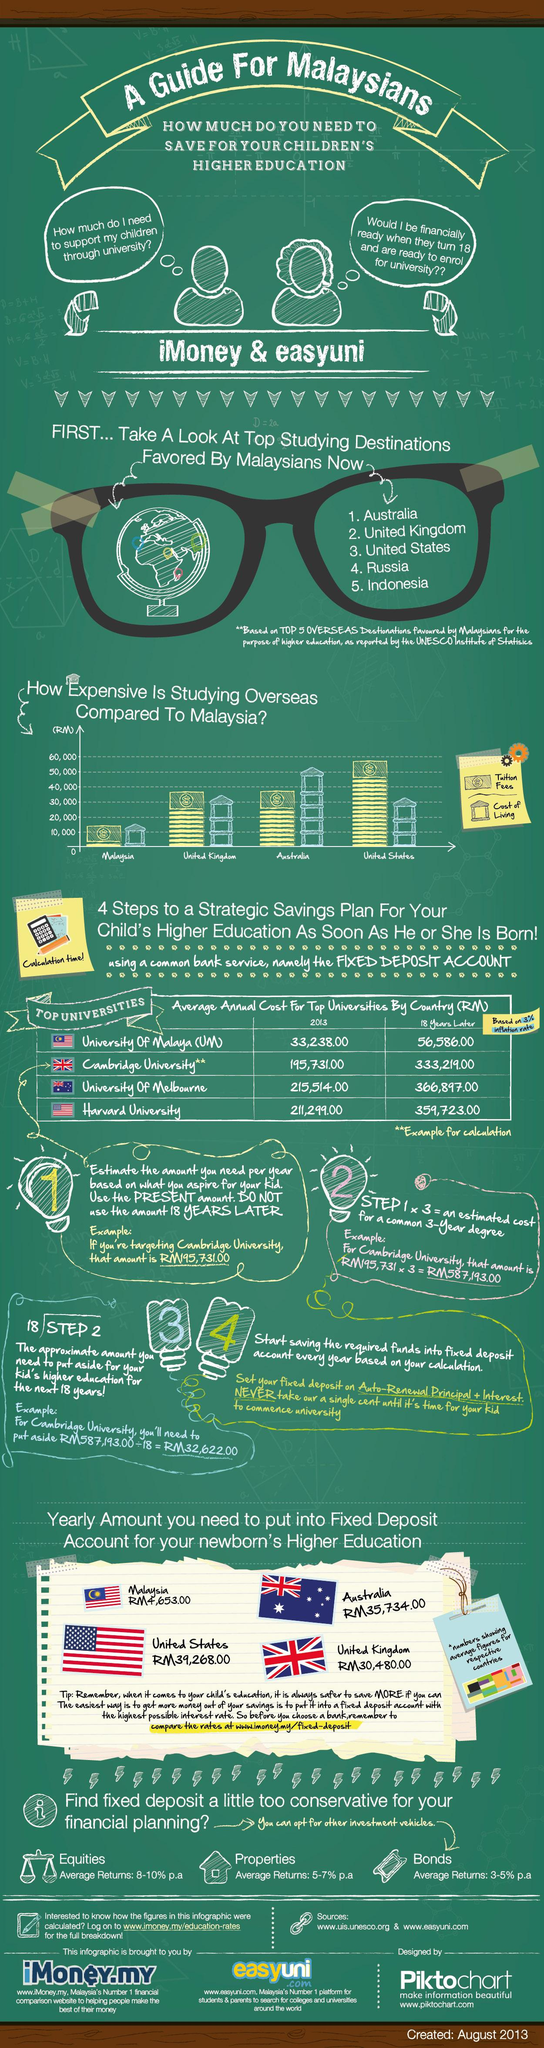Point out several critical features in this image. The average annual cost of studying at Cambridge University in 2013 was 137,488, while the average annual cost in 2018 was 18 years later was 137,488. The average annual cost of studying at the University of Melbourne 18 years later in 2013 was 151,383. The average annual cost at the University of Malaysia for 18 years later and in 2013 is 23348. The yearly amount to put into a fixed deposit account for a newborn's higher education in the United Kingdom is RM30,480.00. The yearly amount required to put into a fixed deposit account for the newborn's higher education in Australia is RM35,734.00. 